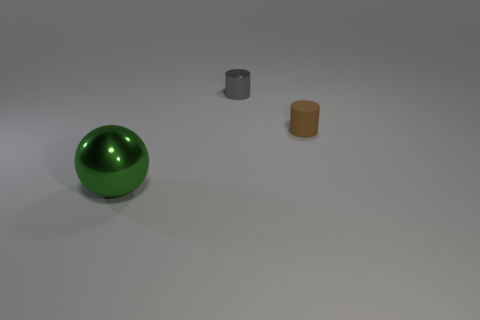Add 2 large gray metal cylinders. How many objects exist? 5 Subtract all cylinders. How many objects are left? 1 Add 3 tiny brown cylinders. How many tiny brown cylinders exist? 4 Subtract 0 blue cylinders. How many objects are left? 3 Subtract all large metal balls. Subtract all gray rubber cylinders. How many objects are left? 2 Add 2 tiny gray cylinders. How many tiny gray cylinders are left? 3 